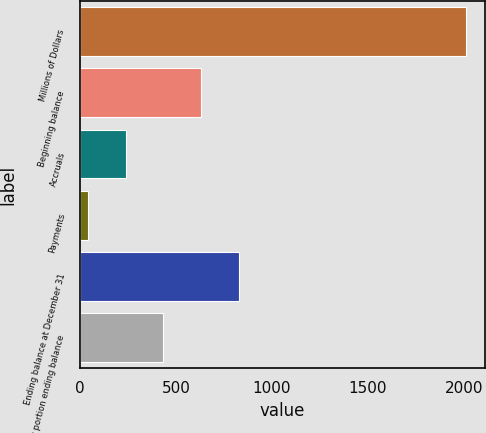Convert chart to OTSL. <chart><loc_0><loc_0><loc_500><loc_500><bar_chart><fcel>Millions of Dollars<fcel>Beginning balance<fcel>Accruals<fcel>Payments<fcel>Ending balance at December 31<fcel>Current portion ending balance<nl><fcel>2009<fcel>631.4<fcel>237.8<fcel>41<fcel>828.2<fcel>434.6<nl></chart> 